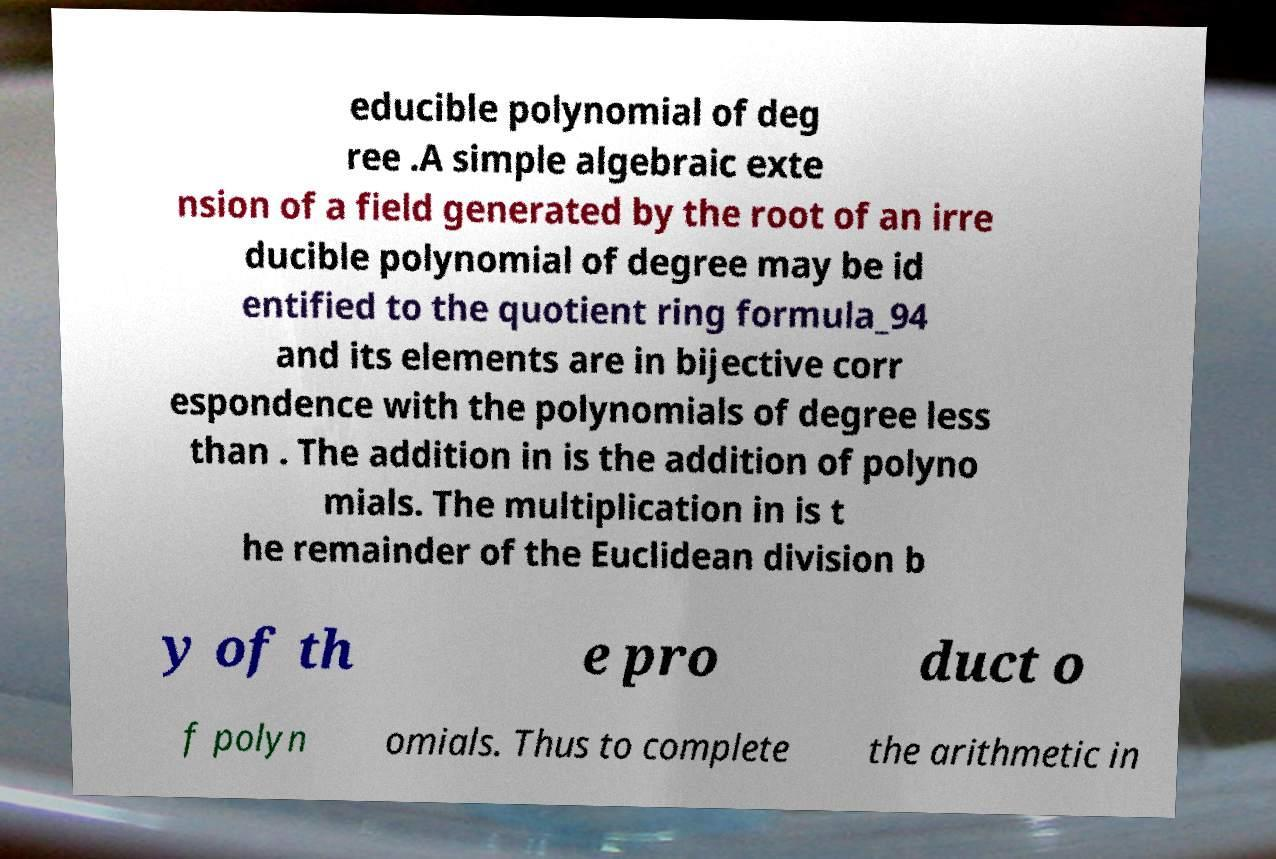Please identify and transcribe the text found in this image. educible polynomial of deg ree .A simple algebraic exte nsion of a field generated by the root of an irre ducible polynomial of degree may be id entified to the quotient ring formula_94 and its elements are in bijective corr espondence with the polynomials of degree less than . The addition in is the addition of polyno mials. The multiplication in is t he remainder of the Euclidean division b y of th e pro duct o f polyn omials. Thus to complete the arithmetic in 